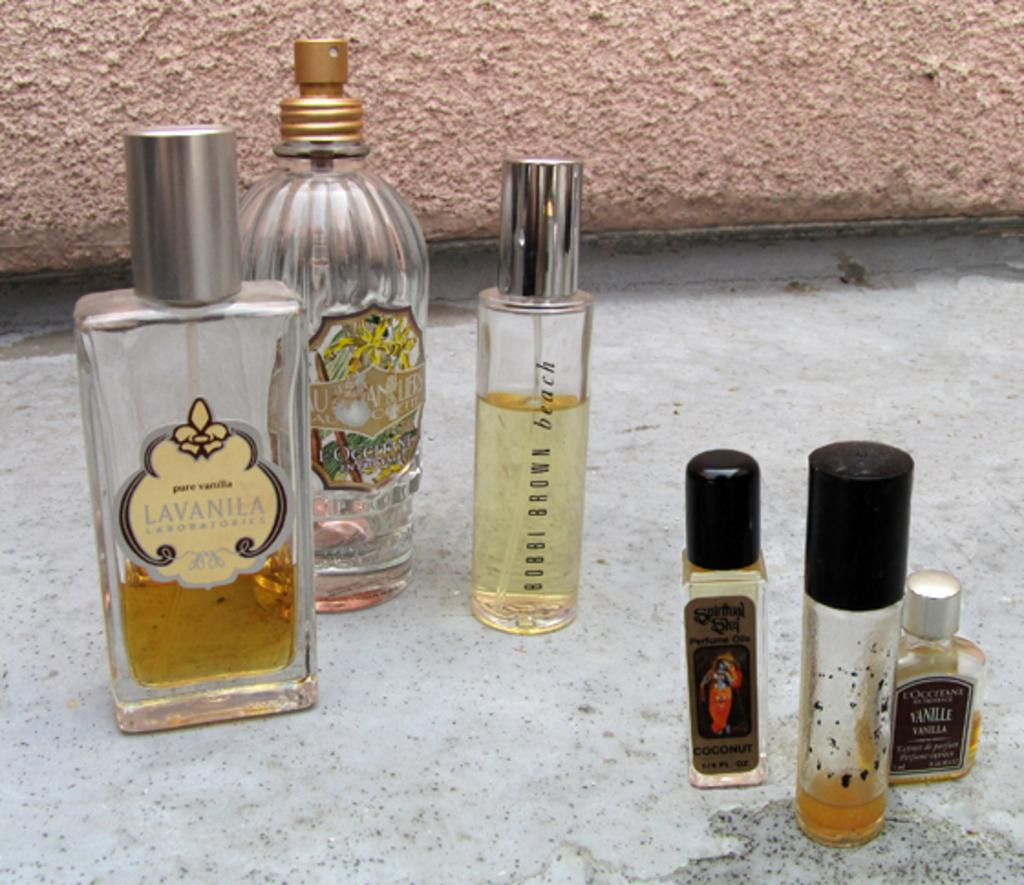Provide a one-sentence caption for the provided image. Bobbi Brown beach sits between five other perfumes. 